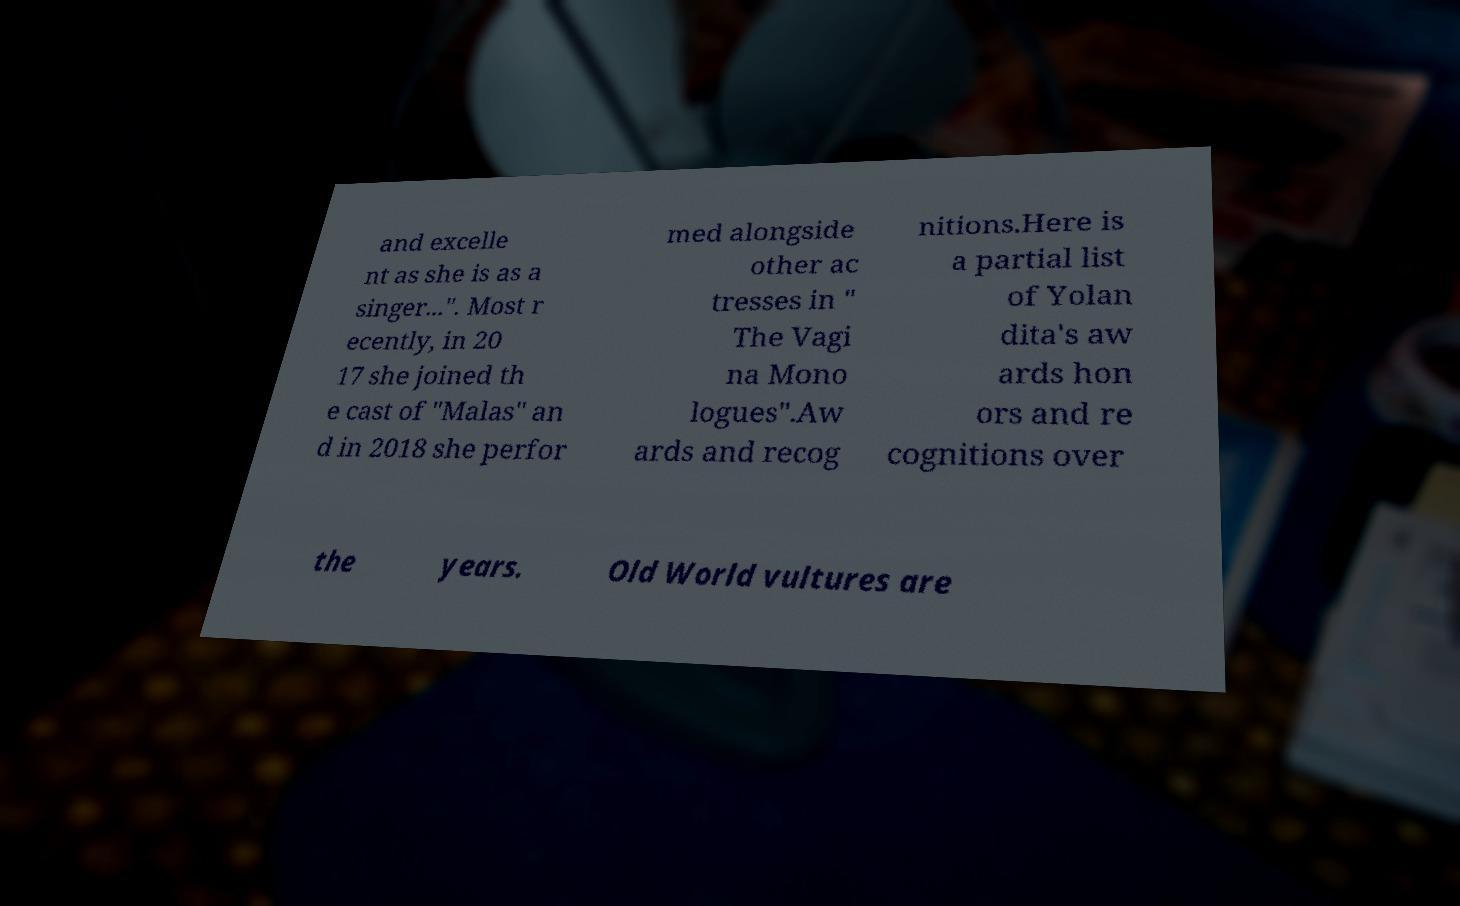Please read and relay the text visible in this image. What does it say? and excelle nt as she is as a singer...". Most r ecently, in 20 17 she joined th e cast of "Malas" an d in 2018 she perfor med alongside other ac tresses in " The Vagi na Mono logues".Aw ards and recog nitions.Here is a partial list of Yolan dita's aw ards hon ors and re cognitions over the years. Old World vultures are 